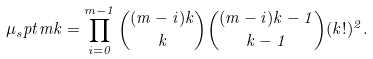<formula> <loc_0><loc_0><loc_500><loc_500>\mu _ { s } p t { m k } = \prod _ { i = 0 } ^ { m - 1 } \binom { ( m - i ) k } { k } \binom { ( m - i ) k - 1 } { k - 1 } ( k ! ) ^ { 2 } .</formula> 